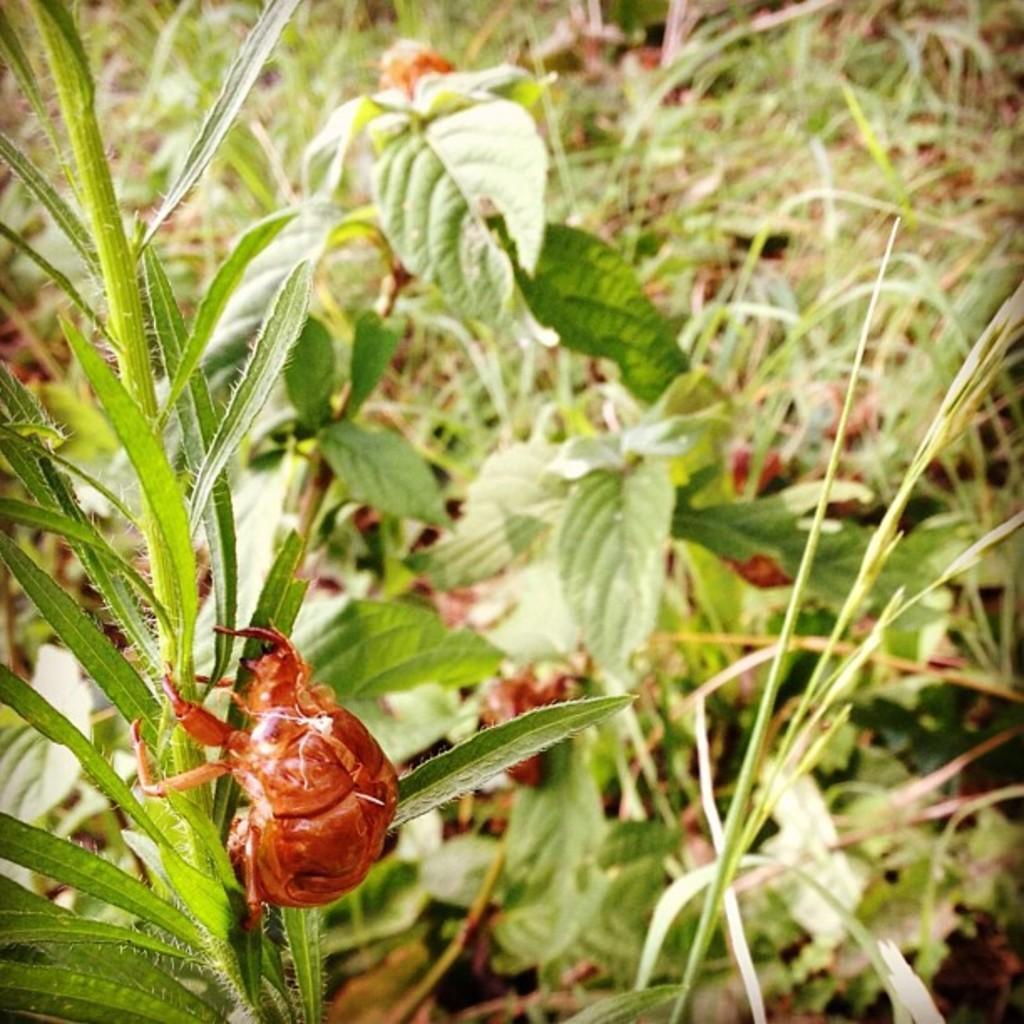Can you describe this image briefly? In the image there is a bug climbing a plant and behind there are many plants. 